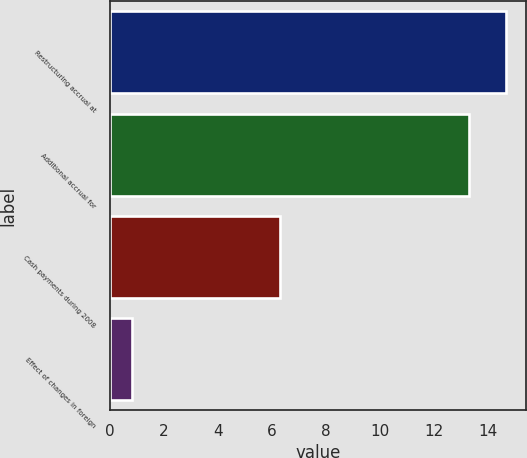<chart> <loc_0><loc_0><loc_500><loc_500><bar_chart><fcel>Restructuring accrual at<fcel>Additional accrual for<fcel>Cash payments during 2008<fcel>Effect of changes in foreign<nl><fcel>14.66<fcel>13.3<fcel>6.3<fcel>0.8<nl></chart> 